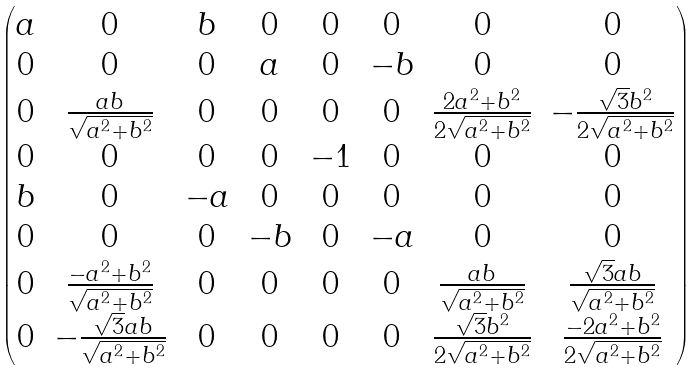<formula> <loc_0><loc_0><loc_500><loc_500>\begin{pmatrix} a & 0 & b & 0 & 0 & 0 & 0 & 0 \\ 0 & 0 & 0 & a & 0 & - b & 0 & 0 \\ 0 & \frac { a b } { \sqrt { a ^ { 2 } + b ^ { 2 } } } & 0 & 0 & 0 & 0 & \frac { 2 a ^ { 2 } + b ^ { 2 } } { 2 \sqrt { a ^ { 2 } + b ^ { 2 } } } & - \frac { \sqrt { 3 } b ^ { 2 } } { 2 \sqrt { a ^ { 2 } + b ^ { 2 } } } \\ 0 & 0 & 0 & 0 & - 1 & 0 & 0 & 0 \\ b & 0 & - a & 0 & 0 & 0 & 0 & 0 \\ 0 & 0 & 0 & - b & 0 & - a & 0 & 0 \\ 0 & \frac { - a ^ { 2 } + b ^ { 2 } } { \sqrt { a ^ { 2 } + b ^ { 2 } } } & 0 & 0 & 0 & 0 & \frac { a b } { \sqrt { a ^ { 2 } + b ^ { 2 } } } & \frac { \sqrt { 3 } a b } { \sqrt { a ^ { 2 } + b ^ { 2 } } } \\ 0 & - \frac { \sqrt { 3 } a b } { \sqrt { a ^ { 2 } + b ^ { 2 } } } & 0 & 0 & 0 & 0 & \frac { \sqrt { 3 } b ^ { 2 } } { 2 \sqrt { a ^ { 2 } + b ^ { 2 } } } & \frac { - 2 a ^ { 2 } + b ^ { 2 } } { 2 \sqrt { a ^ { 2 } + b ^ { 2 } } } \end{pmatrix}</formula> 